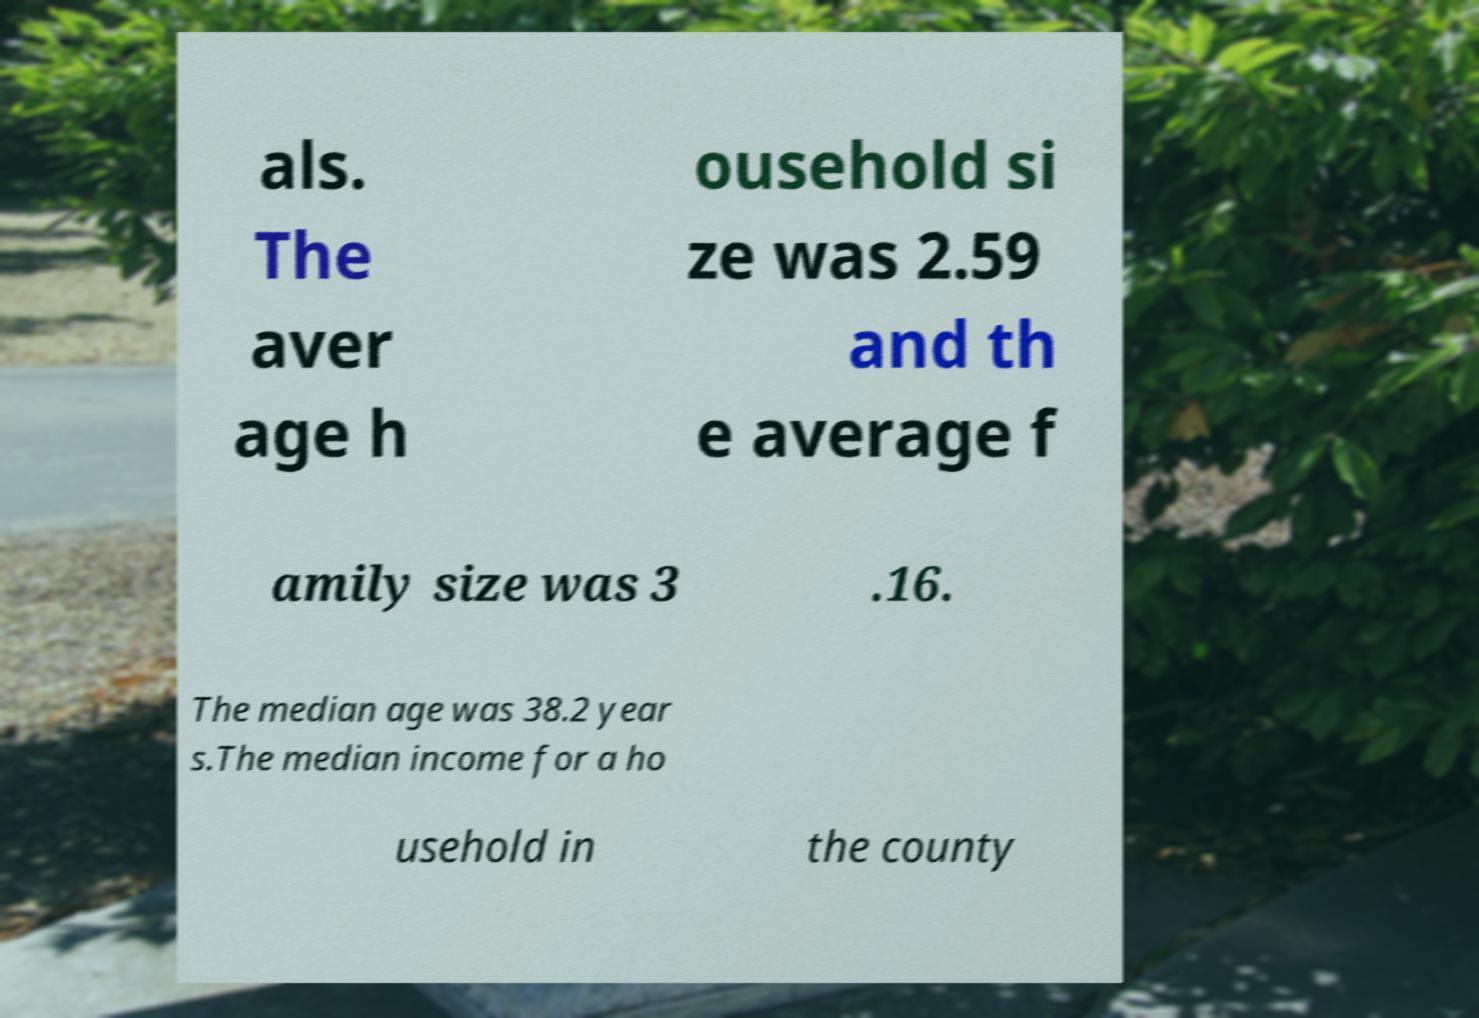Could you extract and type out the text from this image? als. The aver age h ousehold si ze was 2.59 and th e average f amily size was 3 .16. The median age was 38.2 year s.The median income for a ho usehold in the county 